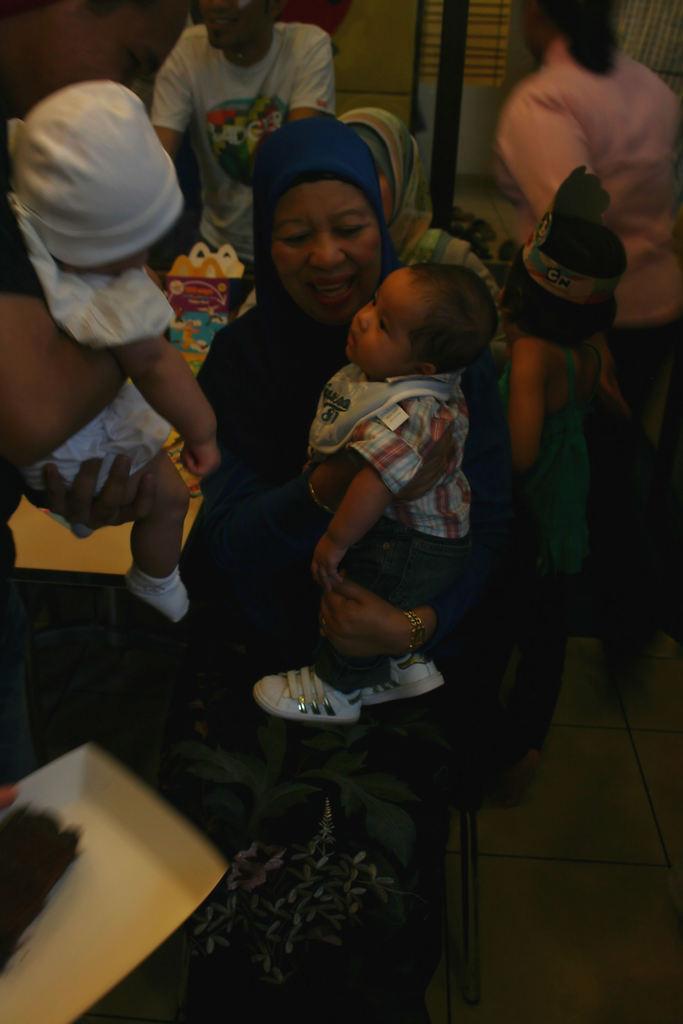Please provide a concise description of this image. In this image I can see group of people. In front the person is holding a kid, the person is wearing black color dress and the kid is wearing multi color shirt. Background I can see few objects and the wall is in cream color. 